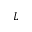<formula> <loc_0><loc_0><loc_500><loc_500>L</formula> 